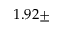Convert formula to latex. <formula><loc_0><loc_0><loc_500><loc_500>1 . 9 2 \pm</formula> 